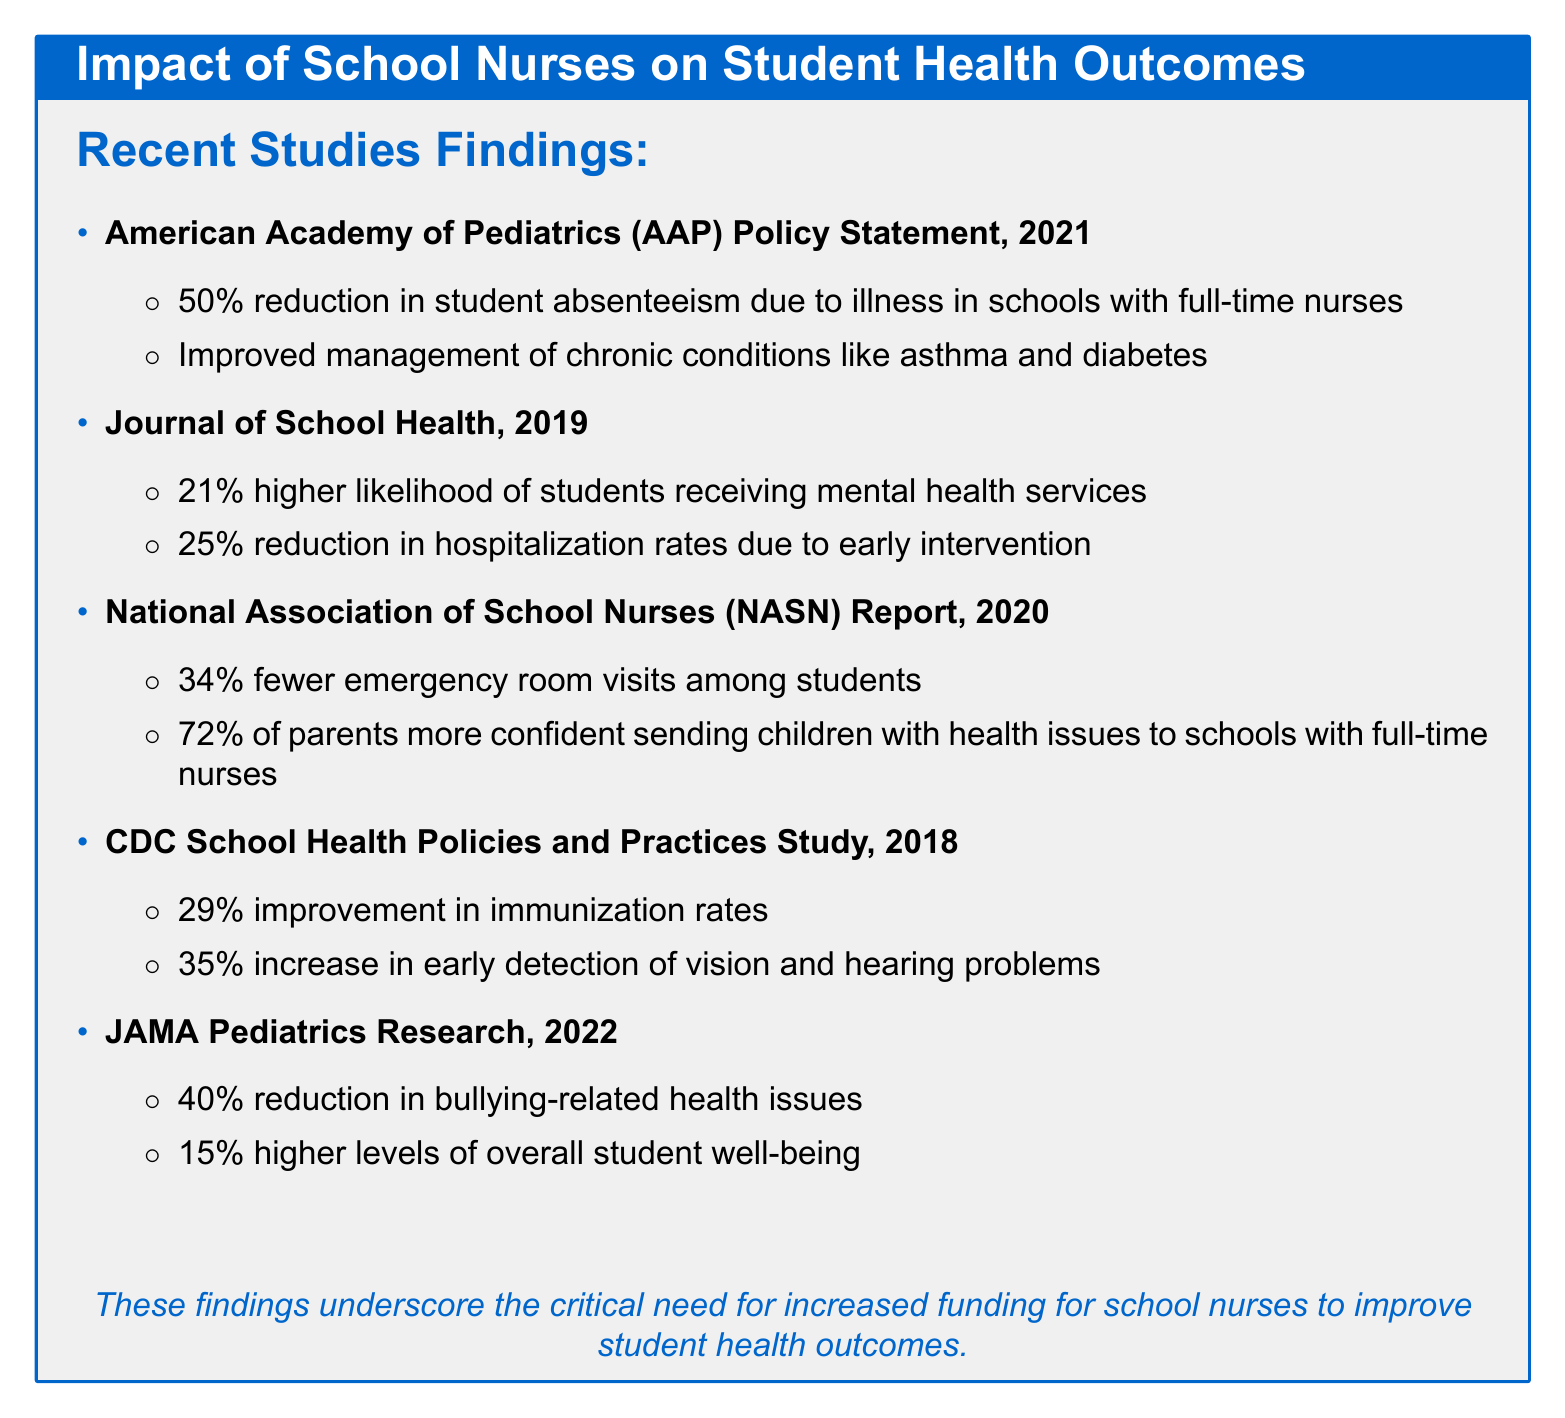What reduction in absenteeism is linked to full-time nurses? The document states that full-time nurses lead to a 50% reduction in student absenteeism due to illness.
Answer: 50% What percentage of parents feel more confident sending children to schools with nurses? According to the document, 72% of parents feel more confident sending children with health issues to schools with full-time nurses.
Answer: 72% What improvement in immunization rates is noted with school nurses? The document notes a 29% improvement in immunization rates in schools with nurses.
Answer: 29% What is the reduction in hospitalization rates due to early intervention by school nurses? The document indicates a 25% reduction in hospitalization rates due to early intervention by school nurses.
Answer: 25% How much higher are students' overall well-being levels in schools with nurses? The document states that students in schools with nurses report 15% higher levels of overall well-being.
Answer: 15% What study reported on the impact of school nurses on emergency room visits? The document cites the National Association of School Nurses (NASN) Report, 2020 regarding emergency room visits.
Answer: National Association of School Nurses (NASN) Report, 2020 Which study indicates a reduction in bullying-related health issues? The document identifies the JAMA Pediatrics Research, 2022 as the study indicating a reduction in bullying-related health issues.
Answer: JAMA Pediatrics Research, 2022 What chronic conditions are mentioned as better managed due to school nurses? The document mentions asthma and diabetes as chronic conditions better managed with the presence of school nurses.
Answer: Asthma and diabetes 